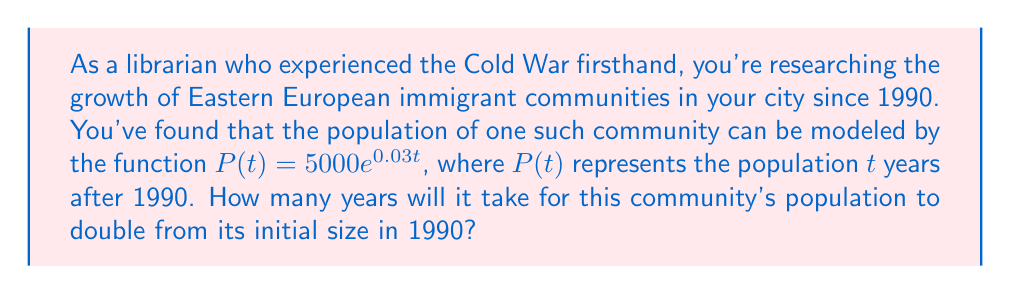Could you help me with this problem? To solve this problem, we'll use the properties of exponential functions and logarithms:

1) The initial population in 1990 (when $t=0$) is:
   $P(0) = 5000e^{0.03(0)} = 5000$

2) We want to find $t$ when the population becomes twice the initial size:
   $P(t) = 2 \cdot 5000 = 10000$

3) Let's set up the equation:
   $5000e^{0.03t} = 10000$

4) Divide both sides by 5000:
   $e^{0.03t} = 2$

5) Take the natural logarithm of both sides:
   $\ln(e^{0.03t}) = \ln(2)$

6) Simplify the left side using the property of logarithms:
   $0.03t = \ln(2)$

7) Solve for $t$:
   $t = \frac{\ln(2)}{0.03}$

8) Calculate the result:
   $t \approx 23.10$ years

Therefore, it will take approximately 23.10 years for the population to double.
Answer: $23.10$ years 